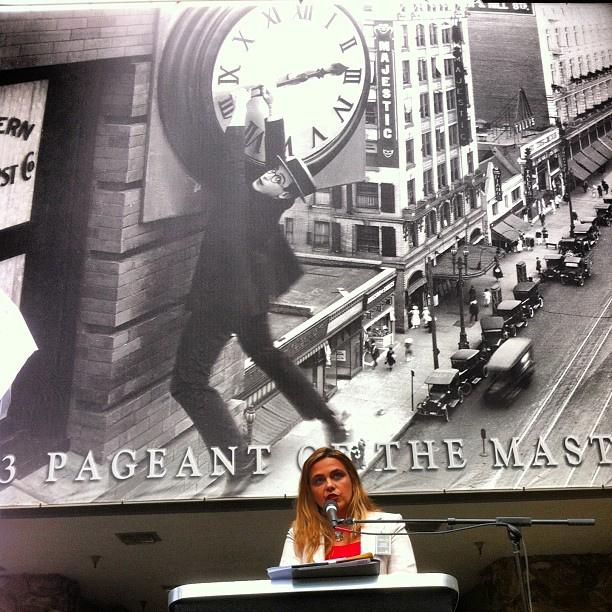What is she speaking into?
Answer briefly. Microphone. What is she doing?
Give a very brief answer. Speaking. What time is it?
Keep it brief. 2:14. 